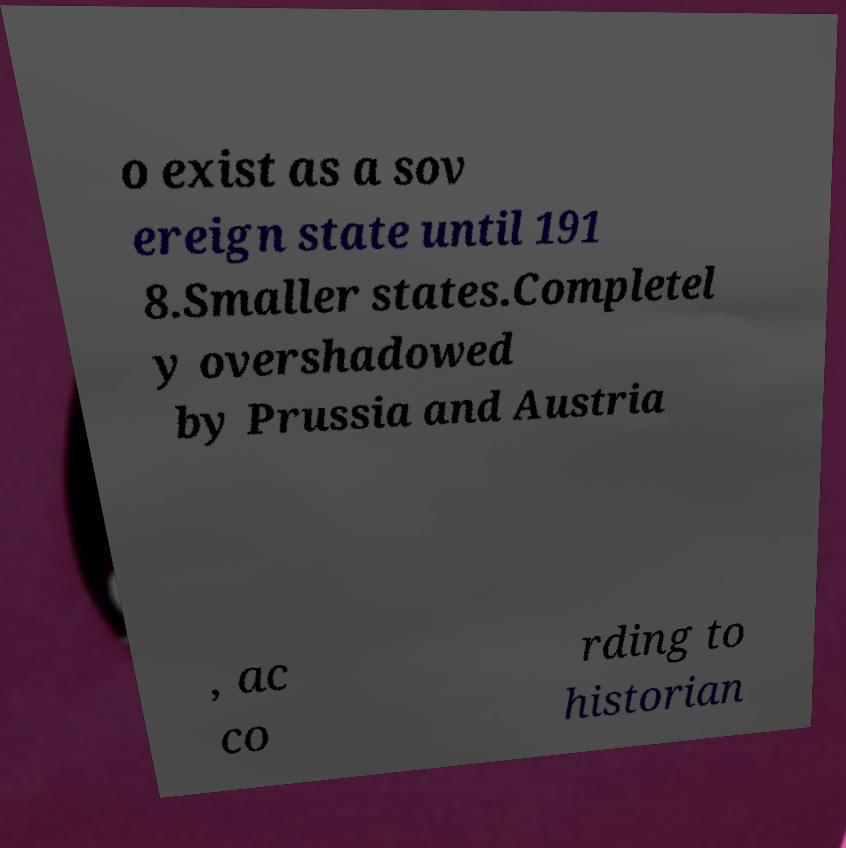I need the written content from this picture converted into text. Can you do that? o exist as a sov ereign state until 191 8.Smaller states.Completel y overshadowed by Prussia and Austria , ac co rding to historian 